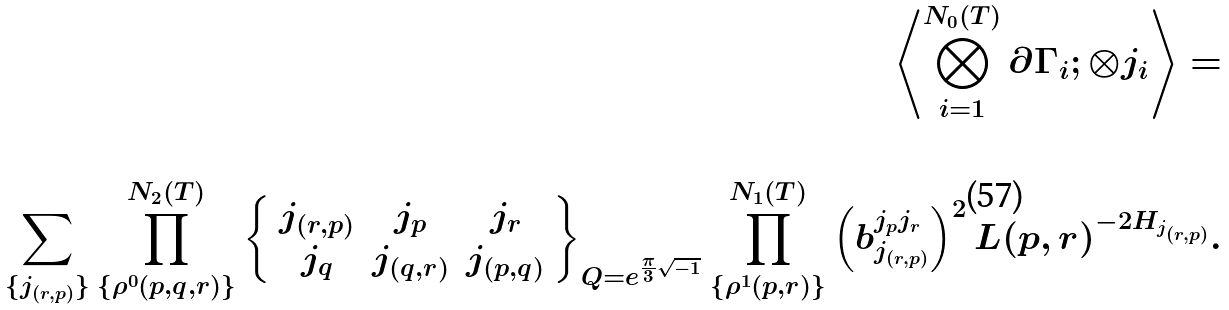<formula> <loc_0><loc_0><loc_500><loc_500>\left \langle \bigotimes _ { i = 1 } ^ { N _ { 0 } ( T ) } \partial \Gamma _ { i } ; \otimes j _ { i } \right \rangle = \\ \\ \sum _ { \{ j _ { ( r , p ) } \} } \prod _ { \{ \rho ^ { 0 } ( p , q , r ) \} } ^ { N _ { 2 } ( T ) } \left \{ \begin{array} { c c c } j _ { ( r , p ) } & j _ { p } & j _ { r } \\ j _ { q } & j _ { ( q , r ) } & j _ { ( p , q ) } \end{array} \right \} _ { Q = e ^ { \frac { \pi } { 3 } \sqrt { - 1 } } } \prod _ { \{ \rho ^ { 1 } ( p , r ) \} } ^ { N _ { 1 } ( T ) } \left ( b _ { j _ { ( r , p ) } } ^ { j _ { p } j _ { r } } \right ) ^ { 2 } L ( p , r ) ^ { - 2 H _ { j _ { ( r , p ) } } } .</formula> 